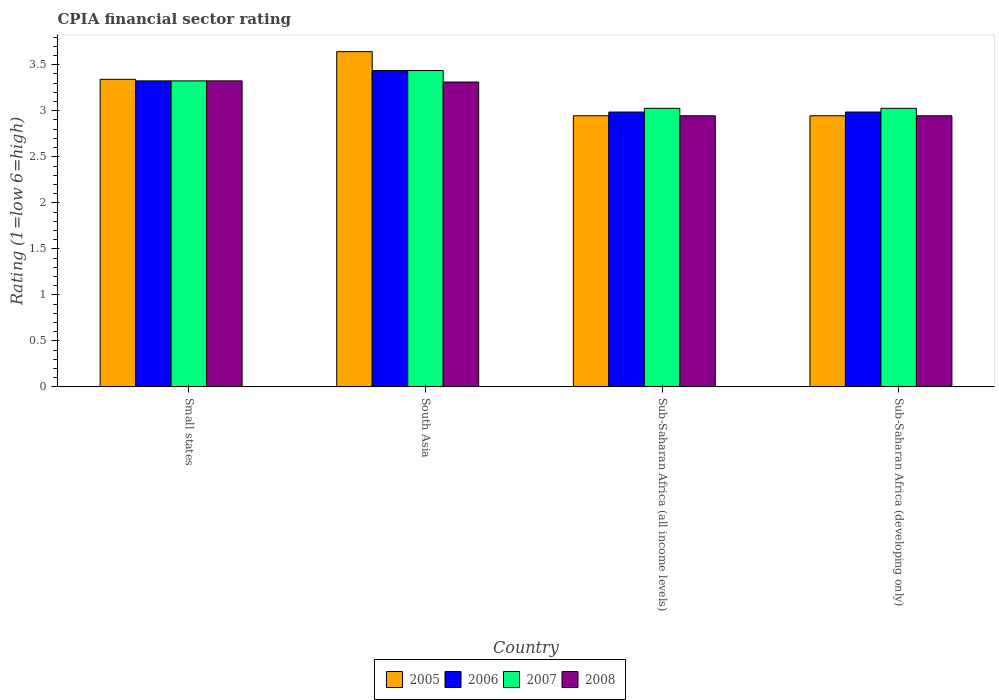How many different coloured bars are there?
Your answer should be very brief. 4. How many groups of bars are there?
Make the answer very short. 4. Are the number of bars per tick equal to the number of legend labels?
Ensure brevity in your answer.  Yes. How many bars are there on the 1st tick from the right?
Provide a short and direct response. 4. What is the label of the 4th group of bars from the left?
Offer a terse response. Sub-Saharan Africa (developing only). In how many cases, is the number of bars for a given country not equal to the number of legend labels?
Offer a terse response. 0. What is the CPIA rating in 2008 in Sub-Saharan Africa (all income levels)?
Your answer should be very brief. 2.95. Across all countries, what is the maximum CPIA rating in 2005?
Offer a very short reply. 3.64. Across all countries, what is the minimum CPIA rating in 2006?
Provide a succinct answer. 2.99. In which country was the CPIA rating in 2005 maximum?
Give a very brief answer. South Asia. In which country was the CPIA rating in 2007 minimum?
Ensure brevity in your answer.  Sub-Saharan Africa (all income levels). What is the total CPIA rating in 2005 in the graph?
Provide a short and direct response. 12.88. What is the difference between the CPIA rating in 2006 in Small states and the CPIA rating in 2007 in Sub-Saharan Africa (developing only)?
Your answer should be compact. 0.3. What is the average CPIA rating in 2005 per country?
Offer a very short reply. 3.22. What is the difference between the CPIA rating of/in 2007 and CPIA rating of/in 2006 in Sub-Saharan Africa (developing only)?
Provide a short and direct response. 0.04. What is the ratio of the CPIA rating in 2007 in Small states to that in Sub-Saharan Africa (all income levels)?
Give a very brief answer. 1.1. Is the difference between the CPIA rating in 2007 in Sub-Saharan Africa (all income levels) and Sub-Saharan Africa (developing only) greater than the difference between the CPIA rating in 2006 in Sub-Saharan Africa (all income levels) and Sub-Saharan Africa (developing only)?
Offer a terse response. No. What is the difference between the highest and the second highest CPIA rating in 2008?
Offer a very short reply. 0.37. What is the difference between the highest and the lowest CPIA rating in 2005?
Give a very brief answer. 0.7. What does the 4th bar from the right in Sub-Saharan Africa (all income levels) represents?
Your answer should be compact. 2005. Is it the case that in every country, the sum of the CPIA rating in 2007 and CPIA rating in 2008 is greater than the CPIA rating in 2006?
Give a very brief answer. Yes. How many bars are there?
Ensure brevity in your answer.  16. How are the legend labels stacked?
Offer a terse response. Horizontal. What is the title of the graph?
Provide a short and direct response. CPIA financial sector rating. Does "2007" appear as one of the legend labels in the graph?
Provide a short and direct response. Yes. What is the label or title of the Y-axis?
Your answer should be compact. Rating (1=low 6=high). What is the Rating (1=low 6=high) of 2005 in Small states?
Make the answer very short. 3.34. What is the Rating (1=low 6=high) of 2006 in Small states?
Offer a terse response. 3.33. What is the Rating (1=low 6=high) in 2007 in Small states?
Ensure brevity in your answer.  3.33. What is the Rating (1=low 6=high) in 2008 in Small states?
Ensure brevity in your answer.  3.33. What is the Rating (1=low 6=high) of 2005 in South Asia?
Keep it short and to the point. 3.64. What is the Rating (1=low 6=high) of 2006 in South Asia?
Your response must be concise. 3.44. What is the Rating (1=low 6=high) in 2007 in South Asia?
Keep it short and to the point. 3.44. What is the Rating (1=low 6=high) in 2008 in South Asia?
Your response must be concise. 3.31. What is the Rating (1=low 6=high) of 2005 in Sub-Saharan Africa (all income levels)?
Provide a succinct answer. 2.95. What is the Rating (1=low 6=high) in 2006 in Sub-Saharan Africa (all income levels)?
Make the answer very short. 2.99. What is the Rating (1=low 6=high) of 2007 in Sub-Saharan Africa (all income levels)?
Provide a short and direct response. 3.03. What is the Rating (1=low 6=high) in 2008 in Sub-Saharan Africa (all income levels)?
Your answer should be compact. 2.95. What is the Rating (1=low 6=high) in 2005 in Sub-Saharan Africa (developing only)?
Your answer should be compact. 2.95. What is the Rating (1=low 6=high) of 2006 in Sub-Saharan Africa (developing only)?
Offer a very short reply. 2.99. What is the Rating (1=low 6=high) in 2007 in Sub-Saharan Africa (developing only)?
Make the answer very short. 3.03. What is the Rating (1=low 6=high) of 2008 in Sub-Saharan Africa (developing only)?
Your answer should be very brief. 2.95. Across all countries, what is the maximum Rating (1=low 6=high) in 2005?
Your answer should be very brief. 3.64. Across all countries, what is the maximum Rating (1=low 6=high) of 2006?
Give a very brief answer. 3.44. Across all countries, what is the maximum Rating (1=low 6=high) of 2007?
Your answer should be compact. 3.44. Across all countries, what is the maximum Rating (1=low 6=high) in 2008?
Make the answer very short. 3.33. Across all countries, what is the minimum Rating (1=low 6=high) in 2005?
Keep it short and to the point. 2.95. Across all countries, what is the minimum Rating (1=low 6=high) in 2006?
Give a very brief answer. 2.99. Across all countries, what is the minimum Rating (1=low 6=high) in 2007?
Your answer should be compact. 3.03. Across all countries, what is the minimum Rating (1=low 6=high) of 2008?
Keep it short and to the point. 2.95. What is the total Rating (1=low 6=high) in 2005 in the graph?
Offer a terse response. 12.88. What is the total Rating (1=low 6=high) in 2006 in the graph?
Your answer should be compact. 12.74. What is the total Rating (1=low 6=high) of 2007 in the graph?
Ensure brevity in your answer.  12.82. What is the total Rating (1=low 6=high) in 2008 in the graph?
Offer a very short reply. 12.53. What is the difference between the Rating (1=low 6=high) of 2005 in Small states and that in South Asia?
Offer a very short reply. -0.3. What is the difference between the Rating (1=low 6=high) of 2006 in Small states and that in South Asia?
Keep it short and to the point. -0.11. What is the difference between the Rating (1=low 6=high) of 2007 in Small states and that in South Asia?
Ensure brevity in your answer.  -0.11. What is the difference between the Rating (1=low 6=high) of 2008 in Small states and that in South Asia?
Your response must be concise. 0.01. What is the difference between the Rating (1=low 6=high) in 2005 in Small states and that in Sub-Saharan Africa (all income levels)?
Give a very brief answer. 0.4. What is the difference between the Rating (1=low 6=high) in 2006 in Small states and that in Sub-Saharan Africa (all income levels)?
Offer a terse response. 0.34. What is the difference between the Rating (1=low 6=high) in 2007 in Small states and that in Sub-Saharan Africa (all income levels)?
Make the answer very short. 0.3. What is the difference between the Rating (1=low 6=high) of 2008 in Small states and that in Sub-Saharan Africa (all income levels)?
Keep it short and to the point. 0.38. What is the difference between the Rating (1=low 6=high) in 2005 in Small states and that in Sub-Saharan Africa (developing only)?
Give a very brief answer. 0.4. What is the difference between the Rating (1=low 6=high) of 2006 in Small states and that in Sub-Saharan Africa (developing only)?
Ensure brevity in your answer.  0.34. What is the difference between the Rating (1=low 6=high) of 2007 in Small states and that in Sub-Saharan Africa (developing only)?
Give a very brief answer. 0.3. What is the difference between the Rating (1=low 6=high) of 2008 in Small states and that in Sub-Saharan Africa (developing only)?
Give a very brief answer. 0.38. What is the difference between the Rating (1=low 6=high) of 2005 in South Asia and that in Sub-Saharan Africa (all income levels)?
Make the answer very short. 0.7. What is the difference between the Rating (1=low 6=high) of 2006 in South Asia and that in Sub-Saharan Africa (all income levels)?
Offer a terse response. 0.45. What is the difference between the Rating (1=low 6=high) in 2007 in South Asia and that in Sub-Saharan Africa (all income levels)?
Your answer should be very brief. 0.41. What is the difference between the Rating (1=low 6=high) of 2008 in South Asia and that in Sub-Saharan Africa (all income levels)?
Give a very brief answer. 0.37. What is the difference between the Rating (1=low 6=high) of 2005 in South Asia and that in Sub-Saharan Africa (developing only)?
Offer a very short reply. 0.7. What is the difference between the Rating (1=low 6=high) in 2006 in South Asia and that in Sub-Saharan Africa (developing only)?
Offer a very short reply. 0.45. What is the difference between the Rating (1=low 6=high) in 2007 in South Asia and that in Sub-Saharan Africa (developing only)?
Make the answer very short. 0.41. What is the difference between the Rating (1=low 6=high) in 2008 in South Asia and that in Sub-Saharan Africa (developing only)?
Your answer should be very brief. 0.37. What is the difference between the Rating (1=low 6=high) in 2005 in Sub-Saharan Africa (all income levels) and that in Sub-Saharan Africa (developing only)?
Ensure brevity in your answer.  0. What is the difference between the Rating (1=low 6=high) in 2006 in Sub-Saharan Africa (all income levels) and that in Sub-Saharan Africa (developing only)?
Give a very brief answer. 0. What is the difference between the Rating (1=low 6=high) of 2005 in Small states and the Rating (1=low 6=high) of 2006 in South Asia?
Provide a short and direct response. -0.1. What is the difference between the Rating (1=low 6=high) of 2005 in Small states and the Rating (1=low 6=high) of 2007 in South Asia?
Your response must be concise. -0.1. What is the difference between the Rating (1=low 6=high) in 2005 in Small states and the Rating (1=low 6=high) in 2008 in South Asia?
Your answer should be compact. 0.03. What is the difference between the Rating (1=low 6=high) of 2006 in Small states and the Rating (1=low 6=high) of 2007 in South Asia?
Give a very brief answer. -0.11. What is the difference between the Rating (1=low 6=high) in 2006 in Small states and the Rating (1=low 6=high) in 2008 in South Asia?
Provide a succinct answer. 0.01. What is the difference between the Rating (1=low 6=high) in 2007 in Small states and the Rating (1=low 6=high) in 2008 in South Asia?
Ensure brevity in your answer.  0.01. What is the difference between the Rating (1=low 6=high) in 2005 in Small states and the Rating (1=low 6=high) in 2006 in Sub-Saharan Africa (all income levels)?
Offer a terse response. 0.36. What is the difference between the Rating (1=low 6=high) in 2005 in Small states and the Rating (1=low 6=high) in 2007 in Sub-Saharan Africa (all income levels)?
Ensure brevity in your answer.  0.32. What is the difference between the Rating (1=low 6=high) of 2005 in Small states and the Rating (1=low 6=high) of 2008 in Sub-Saharan Africa (all income levels)?
Ensure brevity in your answer.  0.4. What is the difference between the Rating (1=low 6=high) in 2006 in Small states and the Rating (1=low 6=high) in 2007 in Sub-Saharan Africa (all income levels)?
Keep it short and to the point. 0.3. What is the difference between the Rating (1=low 6=high) of 2006 in Small states and the Rating (1=low 6=high) of 2008 in Sub-Saharan Africa (all income levels)?
Your answer should be very brief. 0.38. What is the difference between the Rating (1=low 6=high) in 2007 in Small states and the Rating (1=low 6=high) in 2008 in Sub-Saharan Africa (all income levels)?
Offer a very short reply. 0.38. What is the difference between the Rating (1=low 6=high) in 2005 in Small states and the Rating (1=low 6=high) in 2006 in Sub-Saharan Africa (developing only)?
Provide a succinct answer. 0.36. What is the difference between the Rating (1=low 6=high) of 2005 in Small states and the Rating (1=low 6=high) of 2007 in Sub-Saharan Africa (developing only)?
Your answer should be compact. 0.32. What is the difference between the Rating (1=low 6=high) of 2005 in Small states and the Rating (1=low 6=high) of 2008 in Sub-Saharan Africa (developing only)?
Offer a very short reply. 0.4. What is the difference between the Rating (1=low 6=high) of 2006 in Small states and the Rating (1=low 6=high) of 2007 in Sub-Saharan Africa (developing only)?
Your response must be concise. 0.3. What is the difference between the Rating (1=low 6=high) in 2006 in Small states and the Rating (1=low 6=high) in 2008 in Sub-Saharan Africa (developing only)?
Keep it short and to the point. 0.38. What is the difference between the Rating (1=low 6=high) in 2007 in Small states and the Rating (1=low 6=high) in 2008 in Sub-Saharan Africa (developing only)?
Your answer should be compact. 0.38. What is the difference between the Rating (1=low 6=high) in 2005 in South Asia and the Rating (1=low 6=high) in 2006 in Sub-Saharan Africa (all income levels)?
Your answer should be compact. 0.66. What is the difference between the Rating (1=low 6=high) of 2005 in South Asia and the Rating (1=low 6=high) of 2007 in Sub-Saharan Africa (all income levels)?
Your answer should be very brief. 0.62. What is the difference between the Rating (1=low 6=high) of 2005 in South Asia and the Rating (1=low 6=high) of 2008 in Sub-Saharan Africa (all income levels)?
Your answer should be compact. 0.7. What is the difference between the Rating (1=low 6=high) of 2006 in South Asia and the Rating (1=low 6=high) of 2007 in Sub-Saharan Africa (all income levels)?
Offer a terse response. 0.41. What is the difference between the Rating (1=low 6=high) in 2006 in South Asia and the Rating (1=low 6=high) in 2008 in Sub-Saharan Africa (all income levels)?
Give a very brief answer. 0.49. What is the difference between the Rating (1=low 6=high) in 2007 in South Asia and the Rating (1=low 6=high) in 2008 in Sub-Saharan Africa (all income levels)?
Offer a very short reply. 0.49. What is the difference between the Rating (1=low 6=high) of 2005 in South Asia and the Rating (1=low 6=high) of 2006 in Sub-Saharan Africa (developing only)?
Provide a short and direct response. 0.66. What is the difference between the Rating (1=low 6=high) of 2005 in South Asia and the Rating (1=low 6=high) of 2007 in Sub-Saharan Africa (developing only)?
Your answer should be compact. 0.62. What is the difference between the Rating (1=low 6=high) in 2005 in South Asia and the Rating (1=low 6=high) in 2008 in Sub-Saharan Africa (developing only)?
Your answer should be very brief. 0.7. What is the difference between the Rating (1=low 6=high) of 2006 in South Asia and the Rating (1=low 6=high) of 2007 in Sub-Saharan Africa (developing only)?
Provide a short and direct response. 0.41. What is the difference between the Rating (1=low 6=high) in 2006 in South Asia and the Rating (1=low 6=high) in 2008 in Sub-Saharan Africa (developing only)?
Ensure brevity in your answer.  0.49. What is the difference between the Rating (1=low 6=high) in 2007 in South Asia and the Rating (1=low 6=high) in 2008 in Sub-Saharan Africa (developing only)?
Your answer should be very brief. 0.49. What is the difference between the Rating (1=low 6=high) of 2005 in Sub-Saharan Africa (all income levels) and the Rating (1=low 6=high) of 2006 in Sub-Saharan Africa (developing only)?
Keep it short and to the point. -0.04. What is the difference between the Rating (1=low 6=high) of 2005 in Sub-Saharan Africa (all income levels) and the Rating (1=low 6=high) of 2007 in Sub-Saharan Africa (developing only)?
Your answer should be very brief. -0.08. What is the difference between the Rating (1=low 6=high) of 2005 in Sub-Saharan Africa (all income levels) and the Rating (1=low 6=high) of 2008 in Sub-Saharan Africa (developing only)?
Your answer should be very brief. 0. What is the difference between the Rating (1=low 6=high) of 2006 in Sub-Saharan Africa (all income levels) and the Rating (1=low 6=high) of 2007 in Sub-Saharan Africa (developing only)?
Your answer should be very brief. -0.04. What is the difference between the Rating (1=low 6=high) in 2006 in Sub-Saharan Africa (all income levels) and the Rating (1=low 6=high) in 2008 in Sub-Saharan Africa (developing only)?
Your answer should be compact. 0.04. What is the difference between the Rating (1=low 6=high) of 2007 in Sub-Saharan Africa (all income levels) and the Rating (1=low 6=high) of 2008 in Sub-Saharan Africa (developing only)?
Your response must be concise. 0.08. What is the average Rating (1=low 6=high) of 2005 per country?
Provide a succinct answer. 3.22. What is the average Rating (1=low 6=high) in 2006 per country?
Make the answer very short. 3.18. What is the average Rating (1=low 6=high) in 2007 per country?
Your response must be concise. 3.2. What is the average Rating (1=low 6=high) in 2008 per country?
Give a very brief answer. 3.13. What is the difference between the Rating (1=low 6=high) of 2005 and Rating (1=low 6=high) of 2006 in Small states?
Your answer should be very brief. 0.02. What is the difference between the Rating (1=low 6=high) in 2005 and Rating (1=low 6=high) in 2007 in Small states?
Offer a very short reply. 0.02. What is the difference between the Rating (1=low 6=high) in 2005 and Rating (1=low 6=high) in 2008 in Small states?
Make the answer very short. 0.02. What is the difference between the Rating (1=low 6=high) of 2007 and Rating (1=low 6=high) of 2008 in Small states?
Provide a short and direct response. 0. What is the difference between the Rating (1=low 6=high) in 2005 and Rating (1=low 6=high) in 2006 in South Asia?
Your answer should be compact. 0.21. What is the difference between the Rating (1=low 6=high) in 2005 and Rating (1=low 6=high) in 2007 in South Asia?
Provide a short and direct response. 0.21. What is the difference between the Rating (1=low 6=high) in 2005 and Rating (1=low 6=high) in 2008 in South Asia?
Your response must be concise. 0.33. What is the difference between the Rating (1=low 6=high) of 2006 and Rating (1=low 6=high) of 2007 in South Asia?
Your response must be concise. 0. What is the difference between the Rating (1=low 6=high) in 2006 and Rating (1=low 6=high) in 2008 in South Asia?
Your response must be concise. 0.12. What is the difference between the Rating (1=low 6=high) in 2007 and Rating (1=low 6=high) in 2008 in South Asia?
Ensure brevity in your answer.  0.12. What is the difference between the Rating (1=low 6=high) in 2005 and Rating (1=low 6=high) in 2006 in Sub-Saharan Africa (all income levels)?
Give a very brief answer. -0.04. What is the difference between the Rating (1=low 6=high) in 2005 and Rating (1=low 6=high) in 2007 in Sub-Saharan Africa (all income levels)?
Your answer should be compact. -0.08. What is the difference between the Rating (1=low 6=high) of 2005 and Rating (1=low 6=high) of 2008 in Sub-Saharan Africa (all income levels)?
Provide a short and direct response. 0. What is the difference between the Rating (1=low 6=high) in 2006 and Rating (1=low 6=high) in 2007 in Sub-Saharan Africa (all income levels)?
Your answer should be very brief. -0.04. What is the difference between the Rating (1=low 6=high) in 2006 and Rating (1=low 6=high) in 2008 in Sub-Saharan Africa (all income levels)?
Your answer should be compact. 0.04. What is the difference between the Rating (1=low 6=high) of 2007 and Rating (1=low 6=high) of 2008 in Sub-Saharan Africa (all income levels)?
Your response must be concise. 0.08. What is the difference between the Rating (1=low 6=high) of 2005 and Rating (1=low 6=high) of 2006 in Sub-Saharan Africa (developing only)?
Offer a terse response. -0.04. What is the difference between the Rating (1=low 6=high) in 2005 and Rating (1=low 6=high) in 2007 in Sub-Saharan Africa (developing only)?
Your answer should be compact. -0.08. What is the difference between the Rating (1=low 6=high) of 2005 and Rating (1=low 6=high) of 2008 in Sub-Saharan Africa (developing only)?
Your response must be concise. 0. What is the difference between the Rating (1=low 6=high) of 2006 and Rating (1=low 6=high) of 2007 in Sub-Saharan Africa (developing only)?
Your answer should be very brief. -0.04. What is the difference between the Rating (1=low 6=high) in 2006 and Rating (1=low 6=high) in 2008 in Sub-Saharan Africa (developing only)?
Provide a short and direct response. 0.04. What is the difference between the Rating (1=low 6=high) in 2007 and Rating (1=low 6=high) in 2008 in Sub-Saharan Africa (developing only)?
Your response must be concise. 0.08. What is the ratio of the Rating (1=low 6=high) of 2005 in Small states to that in South Asia?
Keep it short and to the point. 0.92. What is the ratio of the Rating (1=low 6=high) of 2006 in Small states to that in South Asia?
Make the answer very short. 0.97. What is the ratio of the Rating (1=low 6=high) in 2007 in Small states to that in South Asia?
Give a very brief answer. 0.97. What is the ratio of the Rating (1=low 6=high) in 2008 in Small states to that in South Asia?
Give a very brief answer. 1. What is the ratio of the Rating (1=low 6=high) in 2005 in Small states to that in Sub-Saharan Africa (all income levels)?
Make the answer very short. 1.13. What is the ratio of the Rating (1=low 6=high) of 2006 in Small states to that in Sub-Saharan Africa (all income levels)?
Keep it short and to the point. 1.11. What is the ratio of the Rating (1=low 6=high) of 2007 in Small states to that in Sub-Saharan Africa (all income levels)?
Your answer should be compact. 1.1. What is the ratio of the Rating (1=low 6=high) in 2008 in Small states to that in Sub-Saharan Africa (all income levels)?
Offer a very short reply. 1.13. What is the ratio of the Rating (1=low 6=high) of 2005 in Small states to that in Sub-Saharan Africa (developing only)?
Ensure brevity in your answer.  1.13. What is the ratio of the Rating (1=low 6=high) in 2006 in Small states to that in Sub-Saharan Africa (developing only)?
Keep it short and to the point. 1.11. What is the ratio of the Rating (1=low 6=high) of 2007 in Small states to that in Sub-Saharan Africa (developing only)?
Make the answer very short. 1.1. What is the ratio of the Rating (1=low 6=high) in 2008 in Small states to that in Sub-Saharan Africa (developing only)?
Provide a short and direct response. 1.13. What is the ratio of the Rating (1=low 6=high) of 2005 in South Asia to that in Sub-Saharan Africa (all income levels)?
Provide a short and direct response. 1.24. What is the ratio of the Rating (1=low 6=high) in 2006 in South Asia to that in Sub-Saharan Africa (all income levels)?
Keep it short and to the point. 1.15. What is the ratio of the Rating (1=low 6=high) in 2007 in South Asia to that in Sub-Saharan Africa (all income levels)?
Keep it short and to the point. 1.14. What is the ratio of the Rating (1=low 6=high) of 2008 in South Asia to that in Sub-Saharan Africa (all income levels)?
Your answer should be very brief. 1.12. What is the ratio of the Rating (1=low 6=high) of 2005 in South Asia to that in Sub-Saharan Africa (developing only)?
Provide a short and direct response. 1.24. What is the ratio of the Rating (1=low 6=high) of 2006 in South Asia to that in Sub-Saharan Africa (developing only)?
Keep it short and to the point. 1.15. What is the ratio of the Rating (1=low 6=high) of 2007 in South Asia to that in Sub-Saharan Africa (developing only)?
Your response must be concise. 1.14. What is the ratio of the Rating (1=low 6=high) of 2008 in South Asia to that in Sub-Saharan Africa (developing only)?
Ensure brevity in your answer.  1.12. What is the ratio of the Rating (1=low 6=high) of 2005 in Sub-Saharan Africa (all income levels) to that in Sub-Saharan Africa (developing only)?
Offer a very short reply. 1. What is the ratio of the Rating (1=low 6=high) in 2006 in Sub-Saharan Africa (all income levels) to that in Sub-Saharan Africa (developing only)?
Your answer should be very brief. 1. What is the ratio of the Rating (1=low 6=high) in 2008 in Sub-Saharan Africa (all income levels) to that in Sub-Saharan Africa (developing only)?
Give a very brief answer. 1. What is the difference between the highest and the second highest Rating (1=low 6=high) in 2005?
Make the answer very short. 0.3. What is the difference between the highest and the second highest Rating (1=low 6=high) of 2006?
Keep it short and to the point. 0.11. What is the difference between the highest and the second highest Rating (1=low 6=high) of 2007?
Give a very brief answer. 0.11. What is the difference between the highest and the second highest Rating (1=low 6=high) in 2008?
Your response must be concise. 0.01. What is the difference between the highest and the lowest Rating (1=low 6=high) of 2005?
Your answer should be compact. 0.7. What is the difference between the highest and the lowest Rating (1=low 6=high) of 2006?
Offer a very short reply. 0.45. What is the difference between the highest and the lowest Rating (1=low 6=high) in 2007?
Your answer should be compact. 0.41. What is the difference between the highest and the lowest Rating (1=low 6=high) of 2008?
Provide a short and direct response. 0.38. 